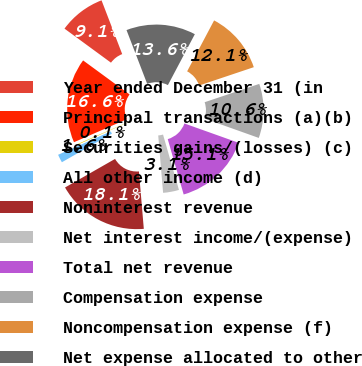Convert chart. <chart><loc_0><loc_0><loc_500><loc_500><pie_chart><fcel>Year ended December 31 (in<fcel>Principal transactions (a)(b)<fcel>Securities gains/(losses) (c)<fcel>All other income (d)<fcel>Noninterest revenue<fcel>Net interest income/(expense)<fcel>Total net revenue<fcel>Compensation expense<fcel>Noncompensation expense (f)<fcel>Net expense allocated to other<nl><fcel>9.1%<fcel>16.59%<fcel>0.12%<fcel>1.61%<fcel>18.09%<fcel>3.11%<fcel>15.09%<fcel>10.6%<fcel>12.1%<fcel>13.59%<nl></chart> 